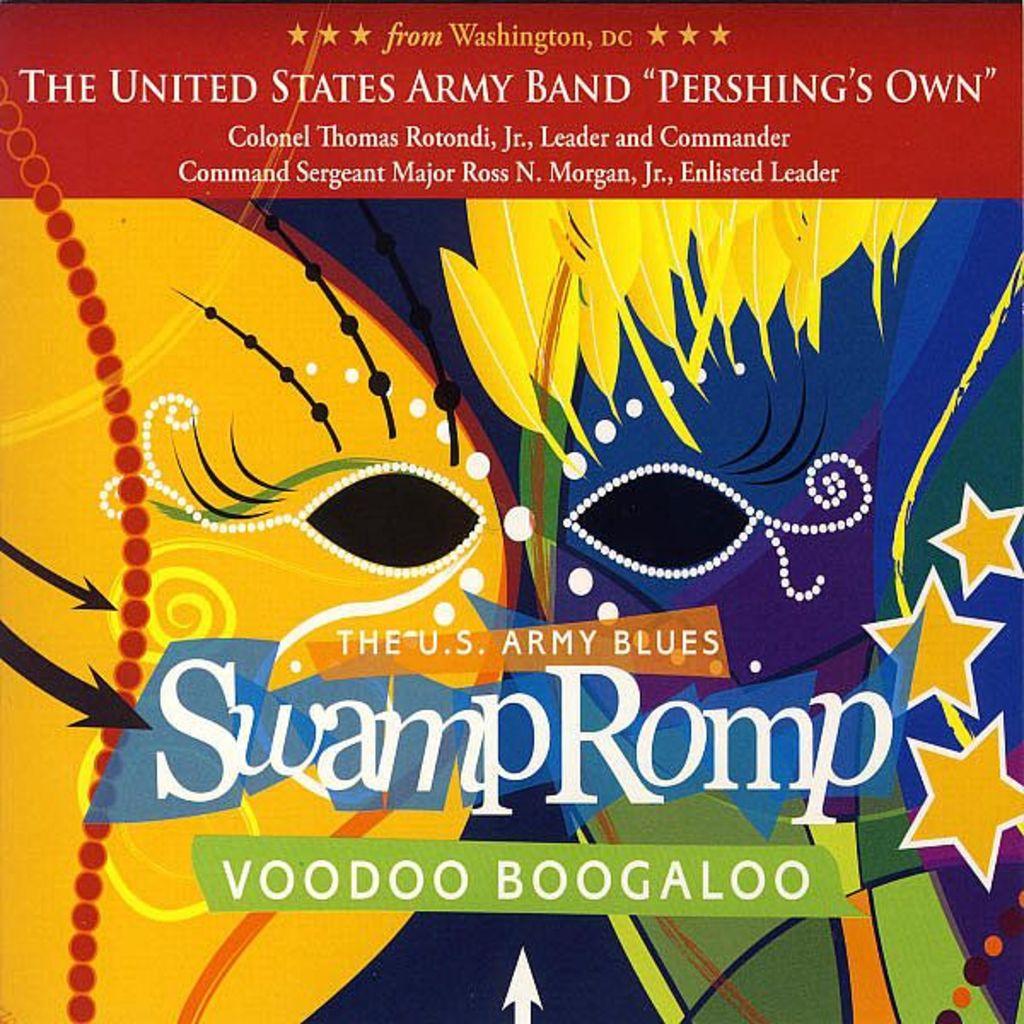What is swamp romp?
Offer a terse response. Voodoo boogaloo. Which branch of military service has presented this album?
Give a very brief answer. Army. 